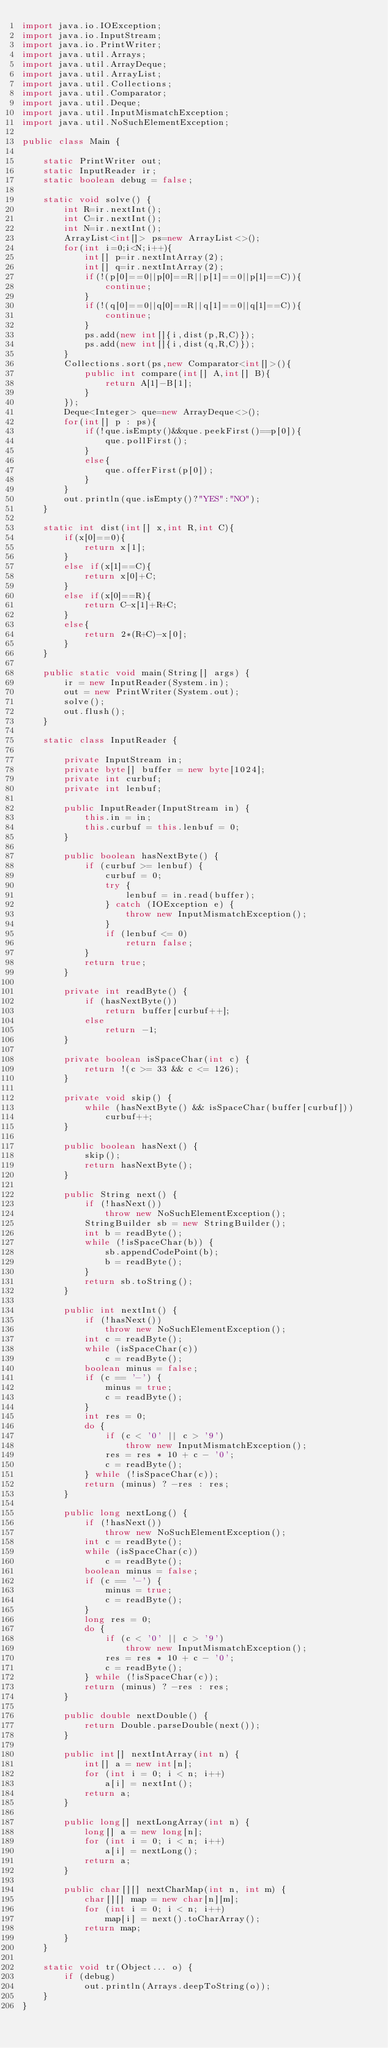<code> <loc_0><loc_0><loc_500><loc_500><_Java_>import java.io.IOException;
import java.io.InputStream;
import java.io.PrintWriter;
import java.util.Arrays;
import java.util.ArrayDeque;
import java.util.ArrayList;
import java.util.Collections;
import java.util.Comparator;
import java.util.Deque;
import java.util.InputMismatchException;
import java.util.NoSuchElementException;

public class Main {

	static PrintWriter out;
	static InputReader ir;
	static boolean debug = false;

	static void solve() {
		int R=ir.nextInt();
		int C=ir.nextInt();
		int N=ir.nextInt();
		ArrayList<int[]> ps=new ArrayList<>();
		for(int i=0;i<N;i++){
			int[] p=ir.nextIntArray(2);
			int[] q=ir.nextIntArray(2);
			if(!(p[0]==0||p[0]==R||p[1]==0||p[1]==C)){
				continue;
			}
			if(!(q[0]==0||q[0]==R||q[1]==0||q[1]==C)){
				continue;
			}
			ps.add(new int[]{i,dist(p,R,C)});
			ps.add(new int[]{i,dist(q,R,C)});
		}
		Collections.sort(ps,new Comparator<int[]>(){
			public int compare(int[] A,int[] B){
				return A[1]-B[1];
			}
		});
		Deque<Integer> que=new ArrayDeque<>();
		for(int[] p : ps){
			if(!que.isEmpty()&&que.peekFirst()==p[0]){
				que.pollFirst();
			}
			else{
				que.offerFirst(p[0]);
			}
		}
		out.println(que.isEmpty()?"YES":"NO");
	}

	static int dist(int[] x,int R,int C){
		if(x[0]==0){
			return x[1];
		}
		else if(x[1]==C){
			return x[0]+C;
		}
		else if(x[0]==R){
			return C-x[1]+R+C;
		}
		else{
			return 2*(R+C)-x[0];
		}
	}

	public static void main(String[] args) {
		ir = new InputReader(System.in);
		out = new PrintWriter(System.out);
		solve();
		out.flush();
	}

	static class InputReader {

		private InputStream in;
		private byte[] buffer = new byte[1024];
		private int curbuf;
		private int lenbuf;

		public InputReader(InputStream in) {
			this.in = in;
			this.curbuf = this.lenbuf = 0;
		}

		public boolean hasNextByte() {
			if (curbuf >= lenbuf) {
				curbuf = 0;
				try {
					lenbuf = in.read(buffer);
				} catch (IOException e) {
					throw new InputMismatchException();
				}
				if (lenbuf <= 0)
					return false;
			}
			return true;
		}

		private int readByte() {
			if (hasNextByte())
				return buffer[curbuf++];
			else
				return -1;
		}

		private boolean isSpaceChar(int c) {
			return !(c >= 33 && c <= 126);
		}

		private void skip() {
			while (hasNextByte() && isSpaceChar(buffer[curbuf]))
				curbuf++;
		}

		public boolean hasNext() {
			skip();
			return hasNextByte();
		}

		public String next() {
			if (!hasNext())
				throw new NoSuchElementException();
			StringBuilder sb = new StringBuilder();
			int b = readByte();
			while (!isSpaceChar(b)) {
				sb.appendCodePoint(b);
				b = readByte();
			}
			return sb.toString();
		}

		public int nextInt() {
			if (!hasNext())
				throw new NoSuchElementException();
			int c = readByte();
			while (isSpaceChar(c))
				c = readByte();
			boolean minus = false;
			if (c == '-') {
				minus = true;
				c = readByte();
			}
			int res = 0;
			do {
				if (c < '0' || c > '9')
					throw new InputMismatchException();
				res = res * 10 + c - '0';
				c = readByte();
			} while (!isSpaceChar(c));
			return (minus) ? -res : res;
		}

		public long nextLong() {
			if (!hasNext())
				throw new NoSuchElementException();
			int c = readByte();
			while (isSpaceChar(c))
				c = readByte();
			boolean minus = false;
			if (c == '-') {
				minus = true;
				c = readByte();
			}
			long res = 0;
			do {
				if (c < '0' || c > '9')
					throw new InputMismatchException();
				res = res * 10 + c - '0';
				c = readByte();
			} while (!isSpaceChar(c));
			return (minus) ? -res : res;
		}

		public double nextDouble() {
			return Double.parseDouble(next());
		}

		public int[] nextIntArray(int n) {
			int[] a = new int[n];
			for (int i = 0; i < n; i++)
				a[i] = nextInt();
			return a;
		}

		public long[] nextLongArray(int n) {
			long[] a = new long[n];
			for (int i = 0; i < n; i++)
				a[i] = nextLong();
			return a;
		}

		public char[][] nextCharMap(int n, int m) {
			char[][] map = new char[n][m];
			for (int i = 0; i < n; i++)
				map[i] = next().toCharArray();
			return map;
		}
	}

	static void tr(Object... o) {
		if (debug)
			out.println(Arrays.deepToString(o));
	}
}
</code> 